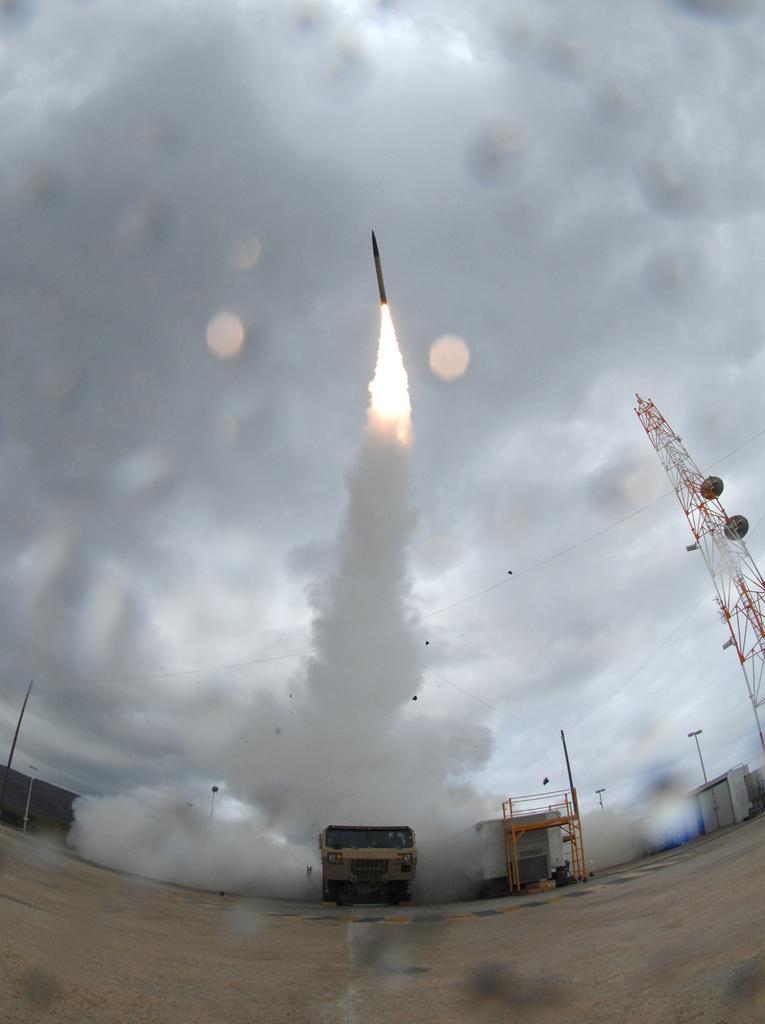In one or two sentences, can you explain what this image depicts? There is a vehicle, metal structure, poles, it seems like stores, shed and smoke in the foreground area, there is a rocket, fire and the sky in the background. 